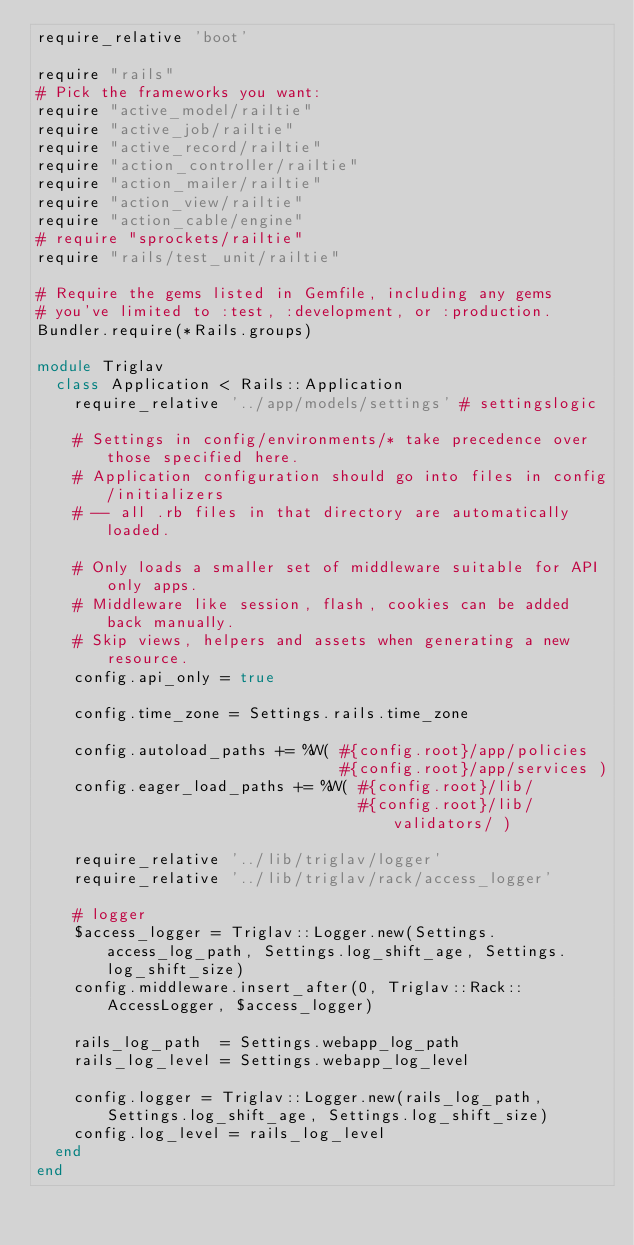Convert code to text. <code><loc_0><loc_0><loc_500><loc_500><_Ruby_>require_relative 'boot'

require "rails"
# Pick the frameworks you want:
require "active_model/railtie"
require "active_job/railtie"
require "active_record/railtie"
require "action_controller/railtie"
require "action_mailer/railtie"
require "action_view/railtie"
require "action_cable/engine"
# require "sprockets/railtie"
require "rails/test_unit/railtie"

# Require the gems listed in Gemfile, including any gems
# you've limited to :test, :development, or :production.
Bundler.require(*Rails.groups)

module Triglav
  class Application < Rails::Application
    require_relative '../app/models/settings' # settingslogic

    # Settings in config/environments/* take precedence over those specified here.
    # Application configuration should go into files in config/initializers
    # -- all .rb files in that directory are automatically loaded.

    # Only loads a smaller set of middleware suitable for API only apps.
    # Middleware like session, flash, cookies can be added back manually.
    # Skip views, helpers and assets when generating a new resource.
    config.api_only = true

    config.time_zone = Settings.rails.time_zone

    config.autoload_paths += %W( #{config.root}/app/policies
                                 #{config.root}/app/services )
    config.eager_load_paths += %W( #{config.root}/lib/
                                   #{config.root}/lib/validators/ )

    require_relative '../lib/triglav/logger'
    require_relative '../lib/triglav/rack/access_logger'

    # logger
    $access_logger = Triglav::Logger.new(Settings.access_log_path, Settings.log_shift_age, Settings.log_shift_size)
    config.middleware.insert_after(0, Triglav::Rack::AccessLogger, $access_logger)

    rails_log_path  = Settings.webapp_log_path
    rails_log_level = Settings.webapp_log_level

    config.logger = Triglav::Logger.new(rails_log_path, Settings.log_shift_age, Settings.log_shift_size)
    config.log_level = rails_log_level
  end
end
</code> 